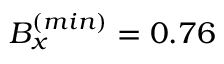Convert formula to latex. <formula><loc_0><loc_0><loc_500><loc_500>B _ { x } ^ { ( \min ) } = 0 . 7 6</formula> 